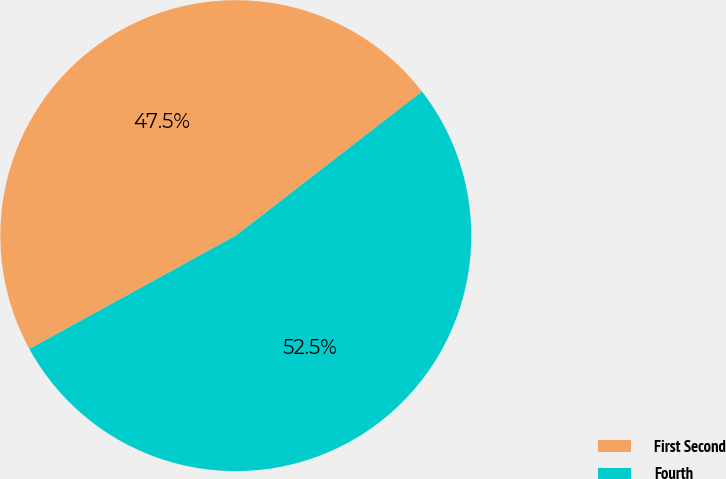Convert chart. <chart><loc_0><loc_0><loc_500><loc_500><pie_chart><fcel>First Second<fcel>Fourth<nl><fcel>47.5%<fcel>52.5%<nl></chart> 